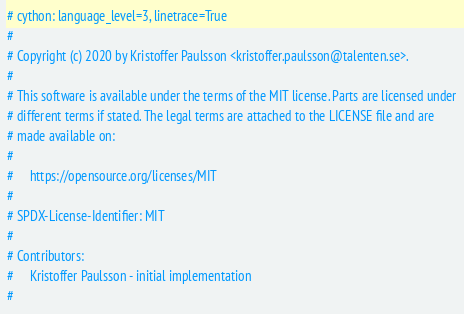Convert code to text. <code><loc_0><loc_0><loc_500><loc_500><_Python_># cython: language_level=3, linetrace=True
#
# Copyright (c) 2020 by Kristoffer Paulsson <kristoffer.paulsson@talenten.se>.
#
# This software is available under the terms of the MIT license. Parts are licensed under
# different terms if stated. The legal terms are attached to the LICENSE file and are
# made available on:
#
#     https://opensource.org/licenses/MIT
#
# SPDX-License-Identifier: MIT
#
# Contributors:
#     Kristoffer Paulsson - initial implementation
#</code> 